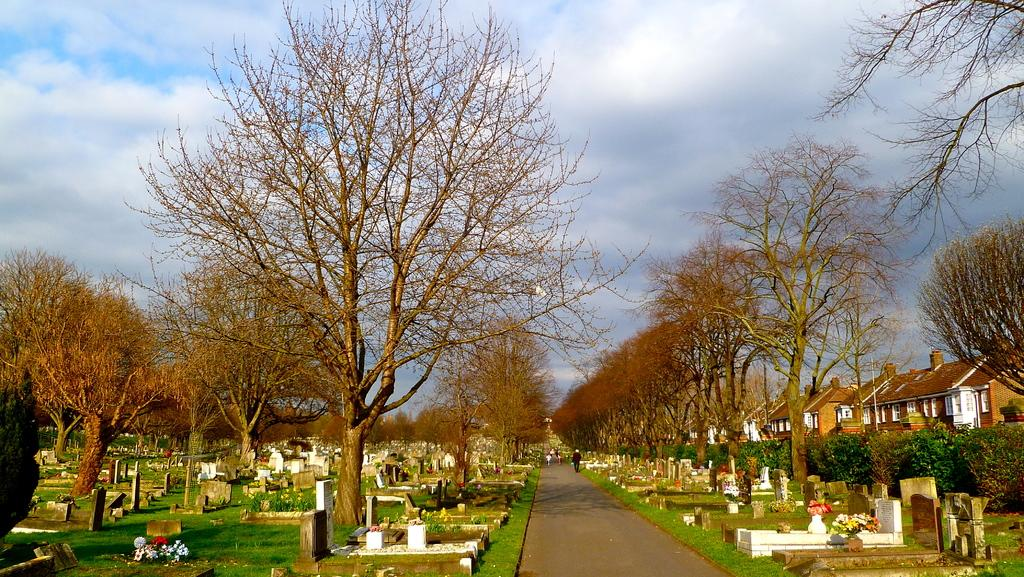What is the main setting of the image? The image depicts a graveyard. What type of trees can be seen in the image? There are bare trees in the image. What celestial bodies are visible in the image? Planets are visible in the image. What type of structures are present in the image? Houses are present in the image. What are the people in the image doing? People are on the road in the image. What is visible in the sky at the top of the image? The sky with clouds is visible at the top of the image. What type of flora is present in the image? There are flowers in the image. What type of match is being played in the image? There is no match being played in the image; it depicts a graveyard with various other elements. What type of metal is used to create the gravestones in the image? The image does not provide enough detail to determine the type of metal used for the gravestones. 